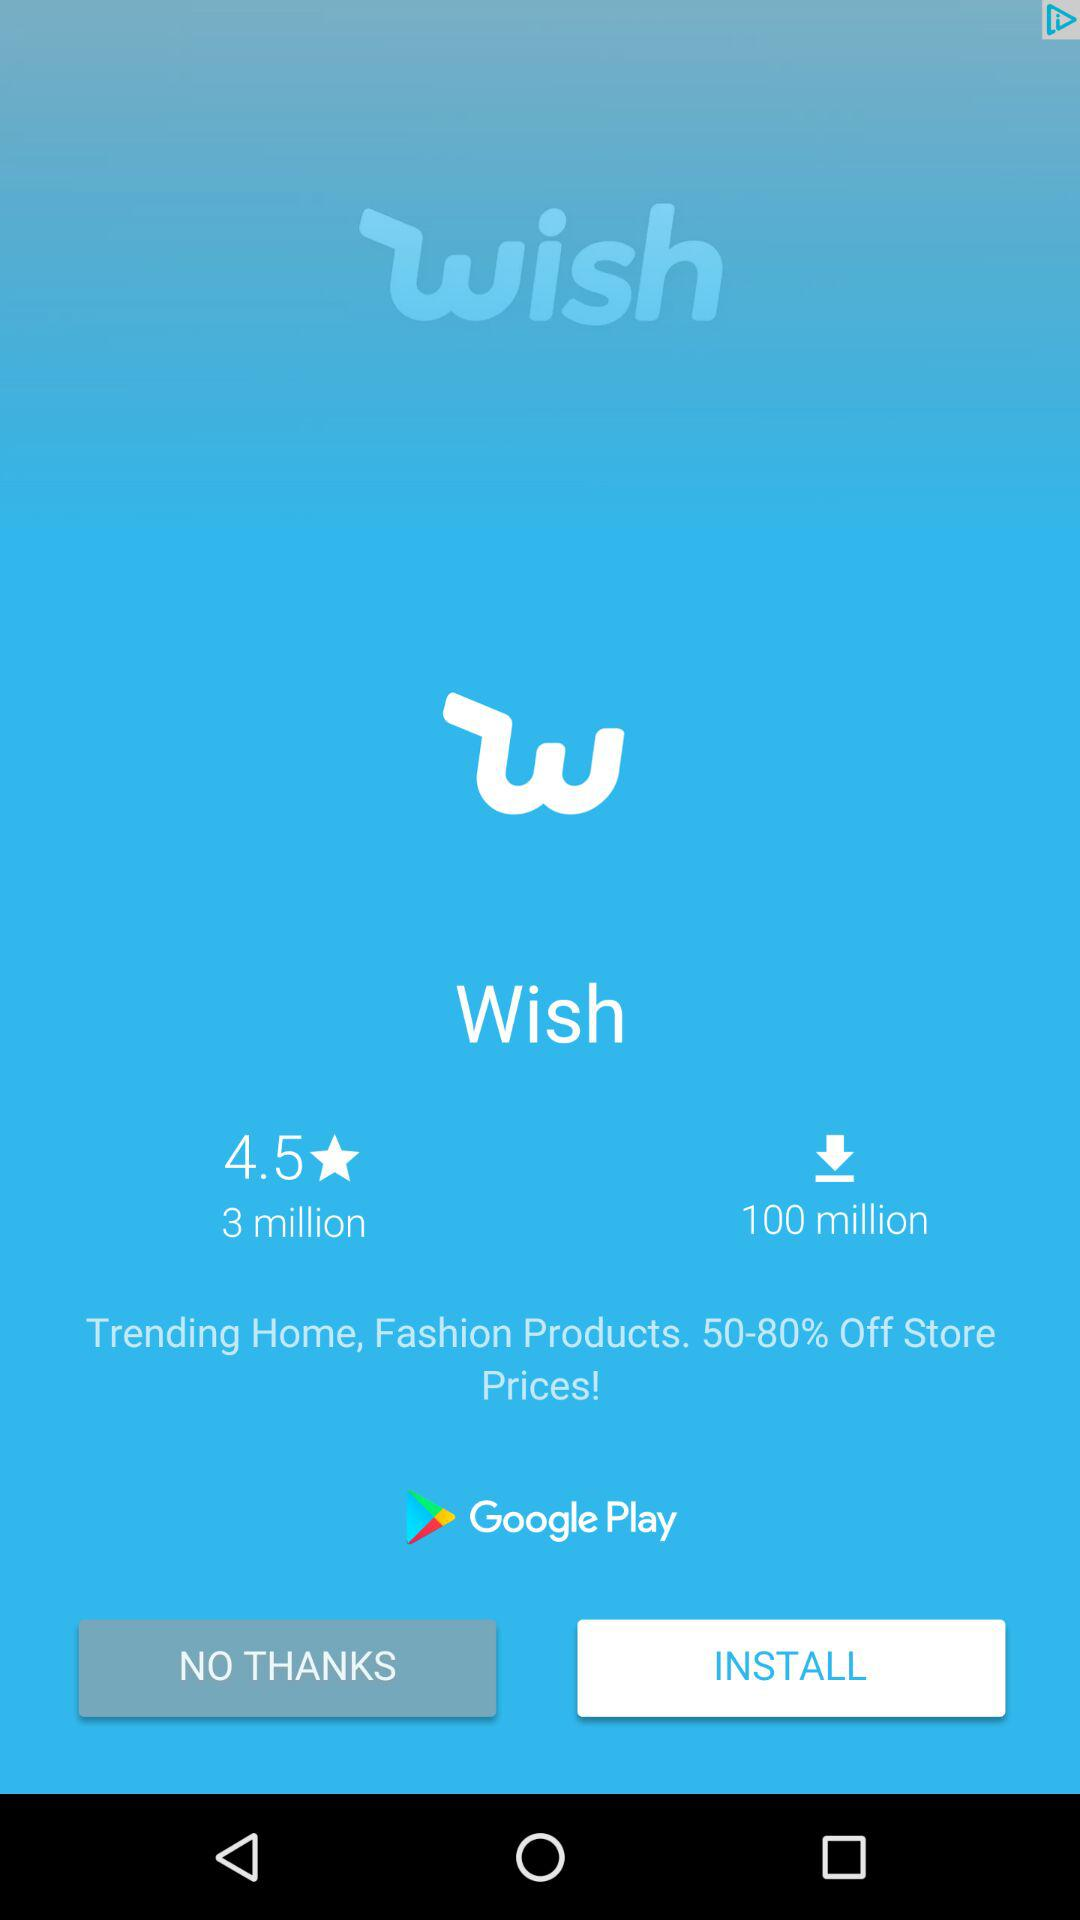How many more downloads does the app have than the number of people who have given it a rating?
Answer the question using a single word or phrase. 97 million 